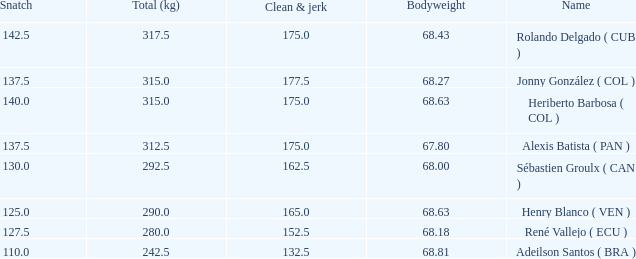Could you help me parse every detail presented in this table? {'header': ['Snatch', 'Total (kg)', 'Clean & jerk', 'Bodyweight', 'Name'], 'rows': [['142.5', '317.5', '175.0', '68.43', 'Rolando Delgado ( CUB )'], ['137.5', '315.0', '177.5', '68.27', 'Jonny González ( COL )'], ['140.0', '315.0', '175.0', '68.63', 'Heriberto Barbosa ( COL )'], ['137.5', '312.5', '175.0', '67.80', 'Alexis Batista ( PAN )'], ['130.0', '292.5', '162.5', '68.00', 'Sébastien Groulx ( CAN )'], ['125.0', '290.0', '165.0', '68.63', 'Henry Blanco ( VEN )'], ['127.5', '280.0', '152.5', '68.18', 'René Vallejo ( ECU )'], ['110.0', '242.5', '132.5', '68.81', 'Adeilson Santos ( BRA )']]} Tell me the total number of snatches for clean and jerk more than 132.5 when the total kg was 315 and bodyweight was 68.63 1.0. 